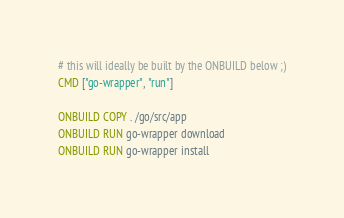Convert code to text. <code><loc_0><loc_0><loc_500><loc_500><_Dockerfile_># this will ideally be built by the ONBUILD below ;)
CMD ["go-wrapper", "run"]

ONBUILD COPY . /go/src/app
ONBUILD RUN go-wrapper download
ONBUILD RUN go-wrapper install
</code> 